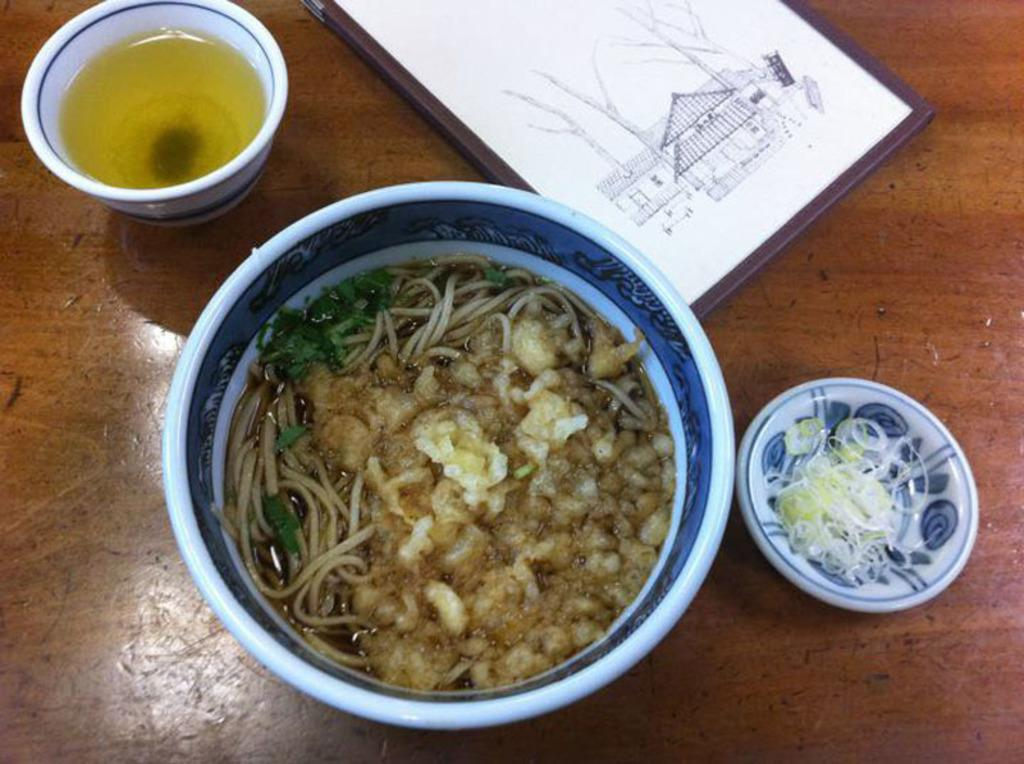What is located at the bottom of the image? There is a table at the bottom of the image. What objects are on the table? There is a bowl, a cup, a saucer, a frame, and food on the table. What is in the bowl on the table? The facts do not specify what is in the bowl, so we cannot answer that question definitively. What is the purpose of the saucer on the table? The saucer is likely used to hold the cup or to catch any spills from the cup. What type of frame is on the table? The facts do not specify the type of frame, so we cannot answer that question definitively. How many friends are sitting on the table in the image? There are no friends sitting on the table in the image. What type of sand can be seen on the table in the image? There is no sand present on the table in the image. 